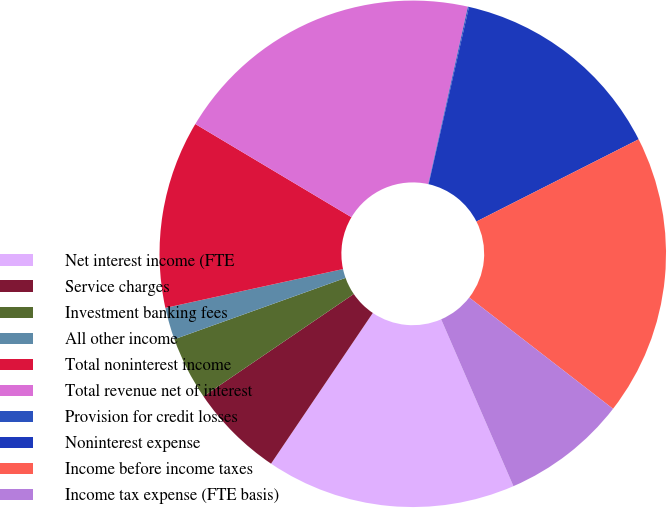Convert chart. <chart><loc_0><loc_0><loc_500><loc_500><pie_chart><fcel>Net interest income (FTE<fcel>Service charges<fcel>Investment banking fees<fcel>All other income<fcel>Total noninterest income<fcel>Total revenue net of interest<fcel>Provision for credit losses<fcel>Noninterest expense<fcel>Income before income taxes<fcel>Income tax expense (FTE basis)<nl><fcel>15.96%<fcel>6.03%<fcel>4.04%<fcel>2.05%<fcel>11.99%<fcel>19.93%<fcel>0.07%<fcel>13.97%<fcel>17.95%<fcel>8.01%<nl></chart> 